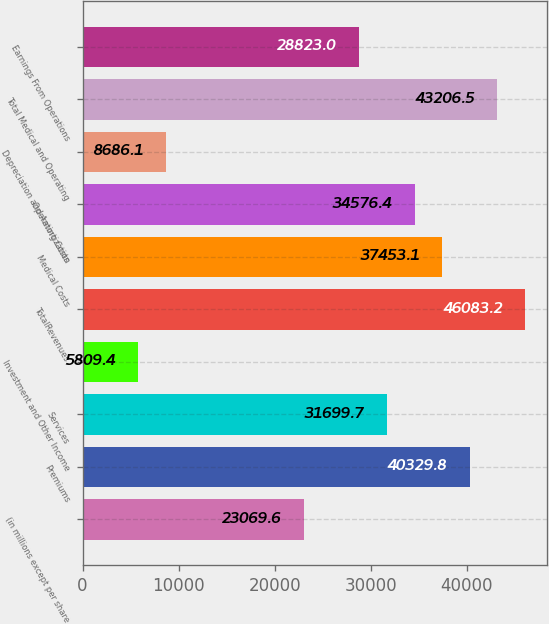Convert chart. <chart><loc_0><loc_0><loc_500><loc_500><bar_chart><fcel>(in millions except per share<fcel>Premiums<fcel>Services<fcel>Investment and Other Income<fcel>TotalRevenues<fcel>Medical Costs<fcel>Operating Costs<fcel>Depreciation and Amortization<fcel>Total Medical and Operating<fcel>Earnings From Operations<nl><fcel>23069.6<fcel>40329.8<fcel>31699.7<fcel>5809.4<fcel>46083.2<fcel>37453.1<fcel>34576.4<fcel>8686.1<fcel>43206.5<fcel>28823<nl></chart> 